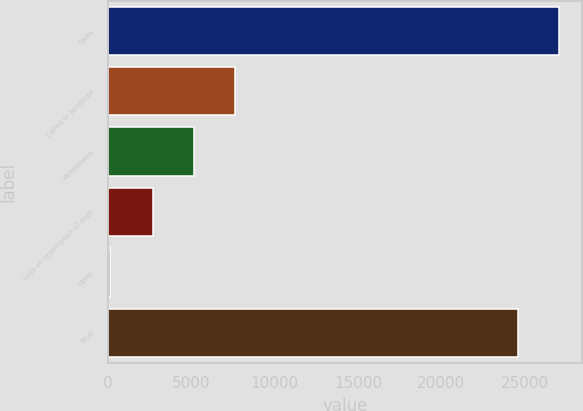Convert chart to OTSL. <chart><loc_0><loc_0><loc_500><loc_500><bar_chart><fcel>Sales<fcel>Called or tendered<fcel>Writedowns<fcel>Loss on redemption of debt<fcel>Other<fcel>Total<nl><fcel>27072.4<fcel>7633.8<fcel>5152.4<fcel>2671<fcel>129<fcel>24591<nl></chart> 